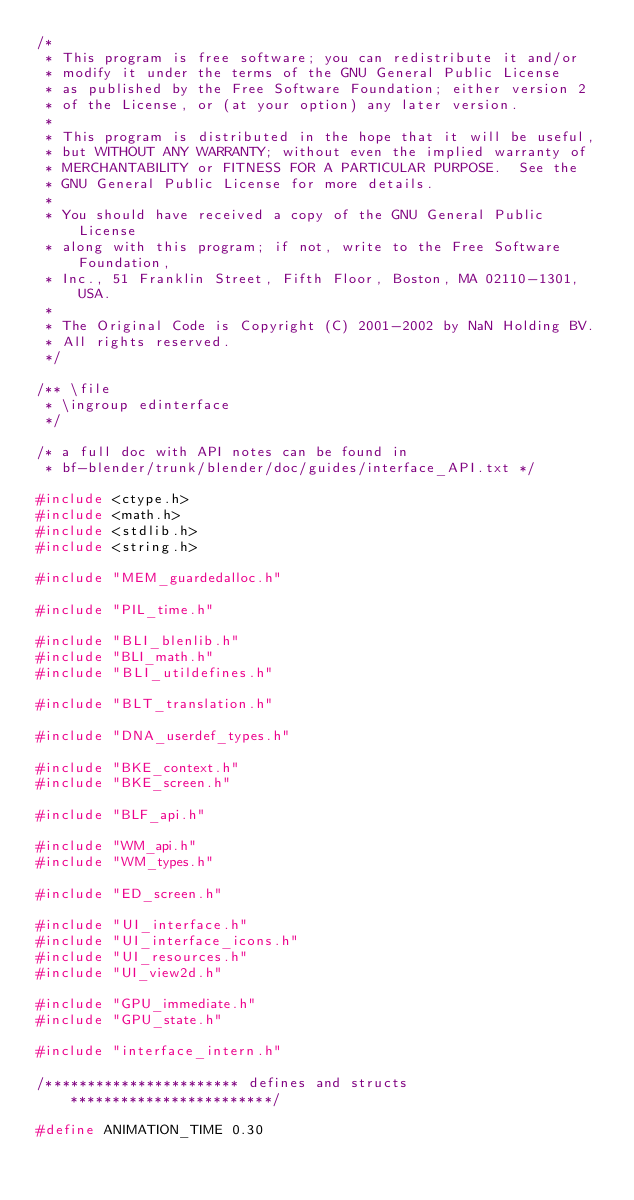<code> <loc_0><loc_0><loc_500><loc_500><_C_>/*
 * This program is free software; you can redistribute it and/or
 * modify it under the terms of the GNU General Public License
 * as published by the Free Software Foundation; either version 2
 * of the License, or (at your option) any later version.
 *
 * This program is distributed in the hope that it will be useful,
 * but WITHOUT ANY WARRANTY; without even the implied warranty of
 * MERCHANTABILITY or FITNESS FOR A PARTICULAR PURPOSE.  See the
 * GNU General Public License for more details.
 *
 * You should have received a copy of the GNU General Public License
 * along with this program; if not, write to the Free Software Foundation,
 * Inc., 51 Franklin Street, Fifth Floor, Boston, MA 02110-1301, USA.
 *
 * The Original Code is Copyright (C) 2001-2002 by NaN Holding BV.
 * All rights reserved.
 */

/** \file
 * \ingroup edinterface
 */

/* a full doc with API notes can be found in
 * bf-blender/trunk/blender/doc/guides/interface_API.txt */

#include <ctype.h>
#include <math.h>
#include <stdlib.h>
#include <string.h>

#include "MEM_guardedalloc.h"

#include "PIL_time.h"

#include "BLI_blenlib.h"
#include "BLI_math.h"
#include "BLI_utildefines.h"

#include "BLT_translation.h"

#include "DNA_userdef_types.h"

#include "BKE_context.h"
#include "BKE_screen.h"

#include "BLF_api.h"

#include "WM_api.h"
#include "WM_types.h"

#include "ED_screen.h"

#include "UI_interface.h"
#include "UI_interface_icons.h"
#include "UI_resources.h"
#include "UI_view2d.h"

#include "GPU_immediate.h"
#include "GPU_state.h"

#include "interface_intern.h"

/*********************** defines and structs ************************/

#define ANIMATION_TIME 0.30</code> 